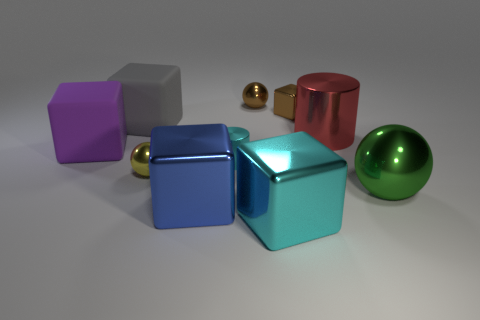What is the shape of the metal object that is the same color as the tiny shiny cube? The shape of the metal object that shares the same hue as the tiny shiny cube is indeed a sphere. This sphere features a lustrous finish reflecting the environment, similar to the small cube's glossy surface. 